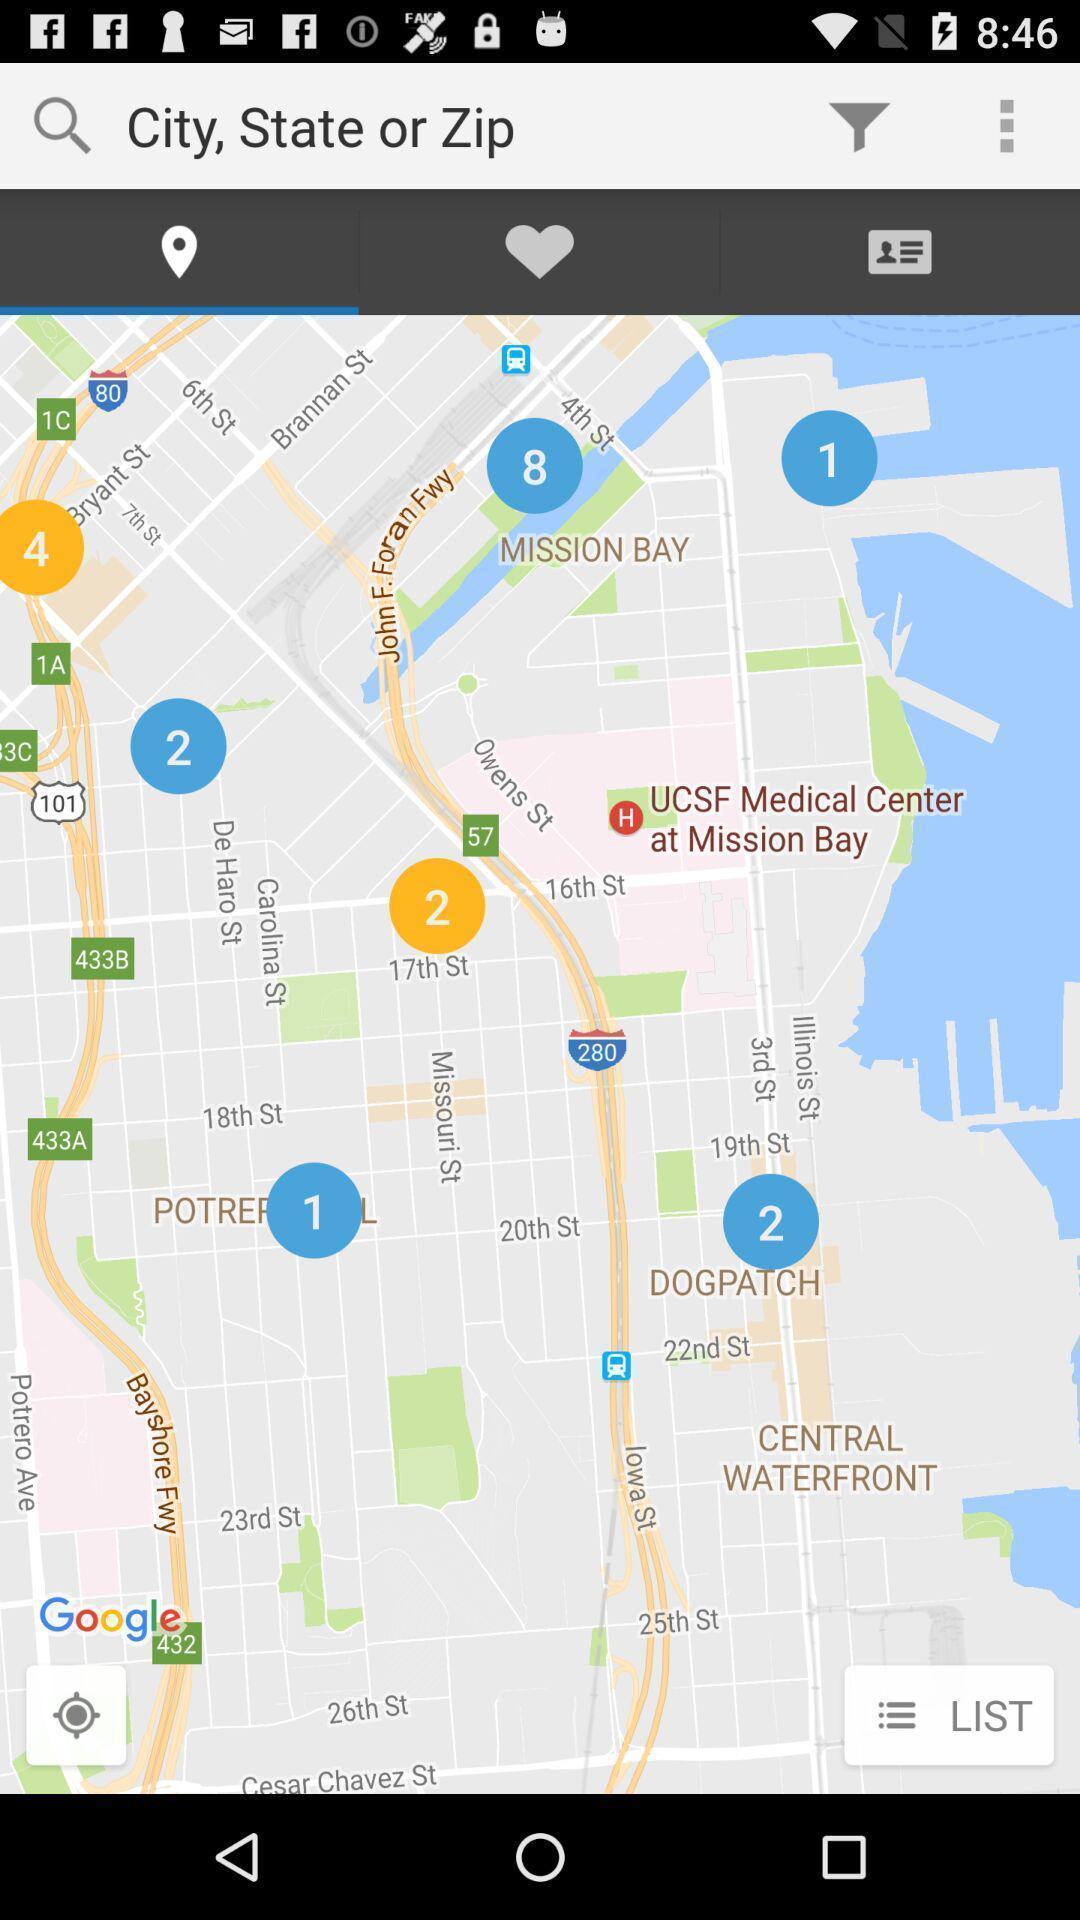Provide a description of this screenshot. Screen shows about a location. 